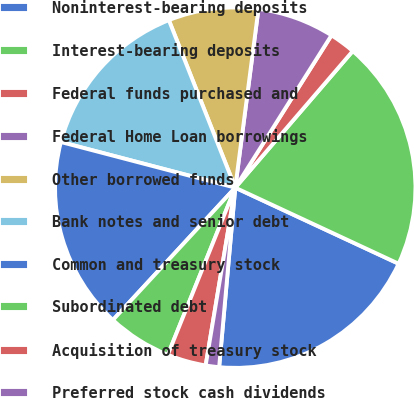Convert chart to OTSL. <chart><loc_0><loc_0><loc_500><loc_500><pie_chart><fcel>Noninterest-bearing deposits<fcel>Interest-bearing deposits<fcel>Federal funds purchased and<fcel>Federal Home Loan borrowings<fcel>Other borrowed funds<fcel>Bank notes and senior debt<fcel>Common and treasury stock<fcel>Subordinated debt<fcel>Acquisition of treasury stock<fcel>Preferred stock cash dividends<nl><fcel>19.49%<fcel>20.63%<fcel>2.34%<fcel>6.91%<fcel>8.06%<fcel>14.92%<fcel>17.2%<fcel>5.77%<fcel>3.48%<fcel>1.2%<nl></chart> 